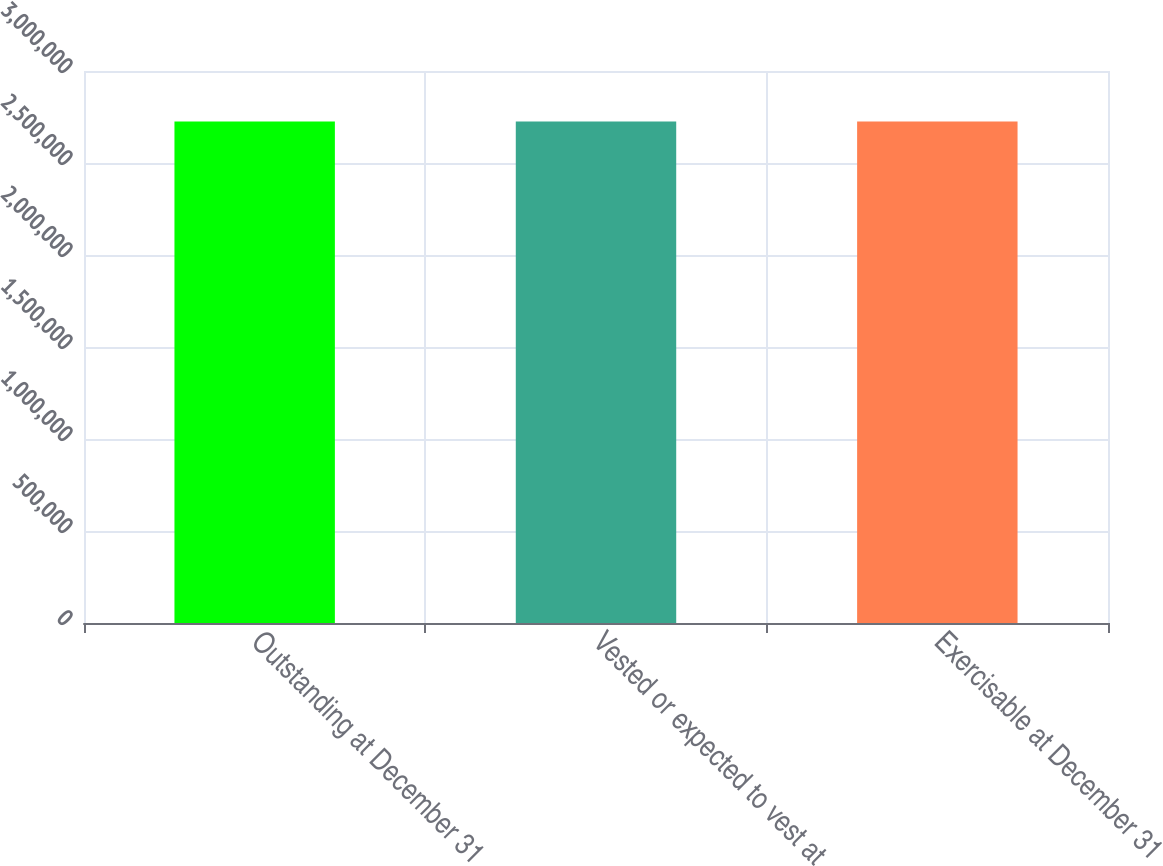Convert chart to OTSL. <chart><loc_0><loc_0><loc_500><loc_500><bar_chart><fcel>Outstanding at December 31<fcel>Vested or expected to vest at<fcel>Exercisable at December 31<nl><fcel>2.7254e+06<fcel>2.7254e+06<fcel>2.7254e+06<nl></chart> 